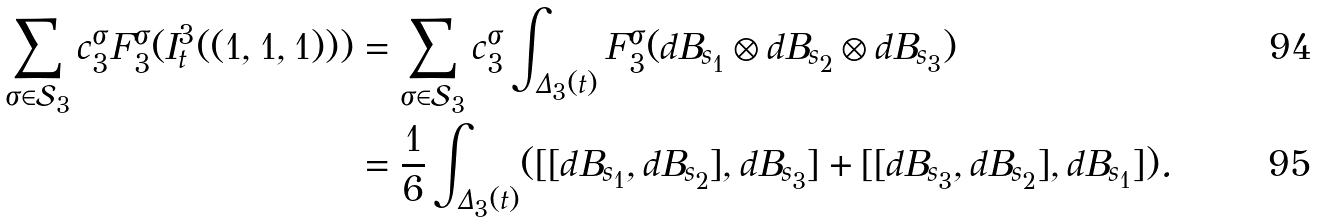Convert formula to latex. <formula><loc_0><loc_0><loc_500><loc_500>\sum _ { \sigma \in \mathcal { S } _ { 3 } } c _ { 3 } ^ { \sigma } F _ { 3 } ^ { \sigma } ( I _ { t } ^ { 3 } ( ( 1 , 1 , 1 ) ) ) & = \sum _ { \sigma \in \mathcal { S } _ { 3 } } c _ { 3 } ^ { \sigma } \int _ { \Delta _ { 3 } ( t ) } F _ { 3 } ^ { \sigma } ( d B _ { s _ { 1 } } \otimes d B _ { s _ { 2 } } \otimes d B _ { s _ { 3 } } ) \\ & = \frac { 1 } { 6 } \int _ { \Delta _ { 3 } ( t ) } ( [ [ d B _ { s _ { 1 } } , d B _ { s _ { 2 } } ] , d B _ { s _ { 3 } } ] + [ [ d B _ { s _ { 3 } } , d B _ { s _ { 2 } } ] , d B _ { s _ { 1 } } ] ) .</formula> 